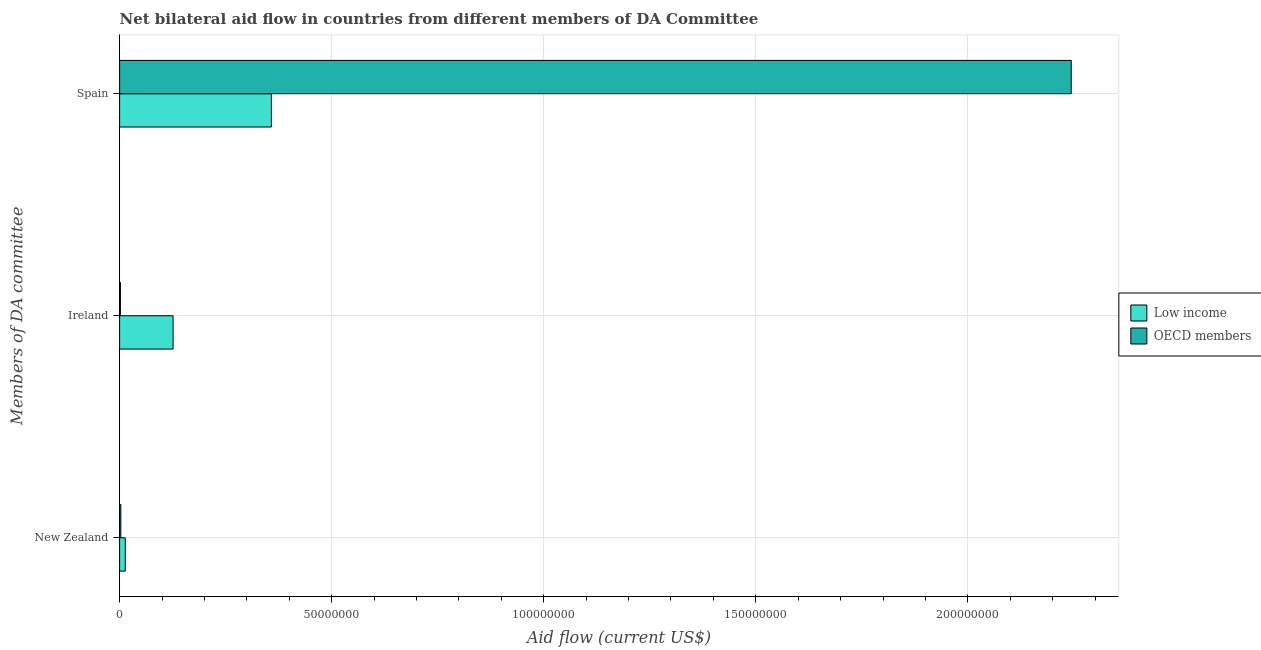How many different coloured bars are there?
Keep it short and to the point. 2. Are the number of bars per tick equal to the number of legend labels?
Ensure brevity in your answer.  Yes. Are the number of bars on each tick of the Y-axis equal?
Keep it short and to the point. Yes. What is the label of the 3rd group of bars from the top?
Offer a terse response. New Zealand. What is the amount of aid provided by ireland in Low income?
Offer a terse response. 1.26e+07. Across all countries, what is the maximum amount of aid provided by ireland?
Your answer should be very brief. 1.26e+07. Across all countries, what is the minimum amount of aid provided by ireland?
Offer a very short reply. 1.90e+05. What is the total amount of aid provided by spain in the graph?
Give a very brief answer. 2.60e+08. What is the difference between the amount of aid provided by new zealand in OECD members and that in Low income?
Make the answer very short. -1.04e+06. What is the difference between the amount of aid provided by new zealand in Low income and the amount of aid provided by ireland in OECD members?
Provide a succinct answer. 1.14e+06. What is the average amount of aid provided by spain per country?
Keep it short and to the point. 1.30e+08. What is the difference between the amount of aid provided by new zealand and amount of aid provided by spain in Low income?
Offer a very short reply. -3.44e+07. In how many countries, is the amount of aid provided by new zealand greater than 210000000 US$?
Your response must be concise. 0. What is the ratio of the amount of aid provided by ireland in Low income to that in OECD members?
Provide a succinct answer. 66.37. Is the amount of aid provided by new zealand in Low income less than that in OECD members?
Provide a short and direct response. No. Is the difference between the amount of aid provided by ireland in OECD members and Low income greater than the difference between the amount of aid provided by new zealand in OECD members and Low income?
Your answer should be compact. No. What is the difference between the highest and the second highest amount of aid provided by new zealand?
Provide a succinct answer. 1.04e+06. What is the difference between the highest and the lowest amount of aid provided by spain?
Your answer should be very brief. 1.89e+08. In how many countries, is the amount of aid provided by ireland greater than the average amount of aid provided by ireland taken over all countries?
Provide a short and direct response. 1. What does the 2nd bar from the top in Spain represents?
Make the answer very short. Low income. Is it the case that in every country, the sum of the amount of aid provided by new zealand and amount of aid provided by ireland is greater than the amount of aid provided by spain?
Your response must be concise. No. How many bars are there?
Your answer should be compact. 6. How many countries are there in the graph?
Keep it short and to the point. 2. What is the difference between two consecutive major ticks on the X-axis?
Offer a very short reply. 5.00e+07. Are the values on the major ticks of X-axis written in scientific E-notation?
Provide a short and direct response. No. How many legend labels are there?
Your response must be concise. 2. How are the legend labels stacked?
Your answer should be very brief. Vertical. What is the title of the graph?
Your answer should be compact. Net bilateral aid flow in countries from different members of DA Committee. Does "Poland" appear as one of the legend labels in the graph?
Offer a very short reply. No. What is the label or title of the X-axis?
Provide a succinct answer. Aid flow (current US$). What is the label or title of the Y-axis?
Your answer should be very brief. Members of DA committee. What is the Aid flow (current US$) of Low income in New Zealand?
Make the answer very short. 1.33e+06. What is the Aid flow (current US$) of Low income in Ireland?
Provide a succinct answer. 1.26e+07. What is the Aid flow (current US$) in Low income in Spain?
Provide a short and direct response. 3.58e+07. What is the Aid flow (current US$) of OECD members in Spain?
Your response must be concise. 2.24e+08. Across all Members of DA committee, what is the maximum Aid flow (current US$) of Low income?
Provide a succinct answer. 3.58e+07. Across all Members of DA committee, what is the maximum Aid flow (current US$) of OECD members?
Provide a short and direct response. 2.24e+08. Across all Members of DA committee, what is the minimum Aid flow (current US$) in Low income?
Your response must be concise. 1.33e+06. What is the total Aid flow (current US$) in Low income in the graph?
Your answer should be very brief. 4.97e+07. What is the total Aid flow (current US$) in OECD members in the graph?
Offer a very short reply. 2.25e+08. What is the difference between the Aid flow (current US$) of Low income in New Zealand and that in Ireland?
Offer a terse response. -1.13e+07. What is the difference between the Aid flow (current US$) in OECD members in New Zealand and that in Ireland?
Provide a short and direct response. 1.00e+05. What is the difference between the Aid flow (current US$) of Low income in New Zealand and that in Spain?
Give a very brief answer. -3.44e+07. What is the difference between the Aid flow (current US$) of OECD members in New Zealand and that in Spain?
Provide a succinct answer. -2.24e+08. What is the difference between the Aid flow (current US$) in Low income in Ireland and that in Spain?
Give a very brief answer. -2.32e+07. What is the difference between the Aid flow (current US$) of OECD members in Ireland and that in Spain?
Your response must be concise. -2.24e+08. What is the difference between the Aid flow (current US$) of Low income in New Zealand and the Aid flow (current US$) of OECD members in Ireland?
Provide a succinct answer. 1.14e+06. What is the difference between the Aid flow (current US$) of Low income in New Zealand and the Aid flow (current US$) of OECD members in Spain?
Provide a short and direct response. -2.23e+08. What is the difference between the Aid flow (current US$) in Low income in Ireland and the Aid flow (current US$) in OECD members in Spain?
Your response must be concise. -2.12e+08. What is the average Aid flow (current US$) in Low income per Members of DA committee?
Your answer should be compact. 1.66e+07. What is the average Aid flow (current US$) in OECD members per Members of DA committee?
Offer a terse response. 7.50e+07. What is the difference between the Aid flow (current US$) in Low income and Aid flow (current US$) in OECD members in New Zealand?
Keep it short and to the point. 1.04e+06. What is the difference between the Aid flow (current US$) in Low income and Aid flow (current US$) in OECD members in Ireland?
Provide a short and direct response. 1.24e+07. What is the difference between the Aid flow (current US$) of Low income and Aid flow (current US$) of OECD members in Spain?
Provide a succinct answer. -1.89e+08. What is the ratio of the Aid flow (current US$) in Low income in New Zealand to that in Ireland?
Offer a terse response. 0.11. What is the ratio of the Aid flow (current US$) of OECD members in New Zealand to that in Ireland?
Keep it short and to the point. 1.53. What is the ratio of the Aid flow (current US$) of Low income in New Zealand to that in Spain?
Give a very brief answer. 0.04. What is the ratio of the Aid flow (current US$) of OECD members in New Zealand to that in Spain?
Keep it short and to the point. 0. What is the ratio of the Aid flow (current US$) of Low income in Ireland to that in Spain?
Your response must be concise. 0.35. What is the ratio of the Aid flow (current US$) of OECD members in Ireland to that in Spain?
Ensure brevity in your answer.  0. What is the difference between the highest and the second highest Aid flow (current US$) in Low income?
Your answer should be compact. 2.32e+07. What is the difference between the highest and the second highest Aid flow (current US$) of OECD members?
Give a very brief answer. 2.24e+08. What is the difference between the highest and the lowest Aid flow (current US$) of Low income?
Offer a very short reply. 3.44e+07. What is the difference between the highest and the lowest Aid flow (current US$) of OECD members?
Offer a very short reply. 2.24e+08. 